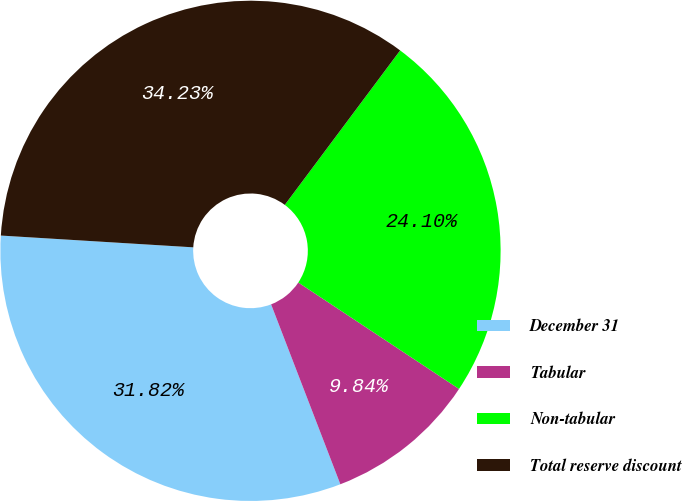Convert chart to OTSL. <chart><loc_0><loc_0><loc_500><loc_500><pie_chart><fcel>December 31<fcel>Tabular<fcel>Non-tabular<fcel>Total reserve discount<nl><fcel>31.82%<fcel>9.84%<fcel>24.1%<fcel>34.23%<nl></chart> 